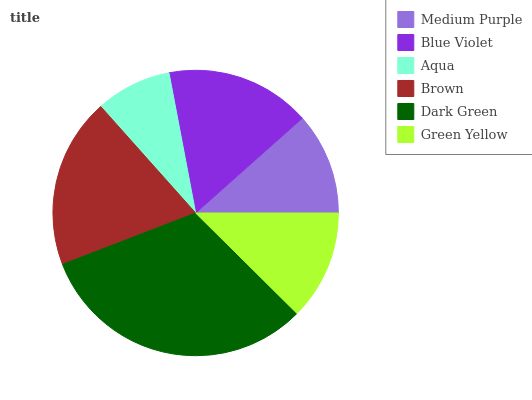Is Aqua the minimum?
Answer yes or no. Yes. Is Dark Green the maximum?
Answer yes or no. Yes. Is Blue Violet the minimum?
Answer yes or no. No. Is Blue Violet the maximum?
Answer yes or no. No. Is Blue Violet greater than Medium Purple?
Answer yes or no. Yes. Is Medium Purple less than Blue Violet?
Answer yes or no. Yes. Is Medium Purple greater than Blue Violet?
Answer yes or no. No. Is Blue Violet less than Medium Purple?
Answer yes or no. No. Is Blue Violet the high median?
Answer yes or no. Yes. Is Green Yellow the low median?
Answer yes or no. Yes. Is Dark Green the high median?
Answer yes or no. No. Is Dark Green the low median?
Answer yes or no. No. 